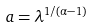Convert formula to latex. <formula><loc_0><loc_0><loc_500><loc_500>a = \lambda ^ { 1 / ( \alpha - 1 ) }</formula> 